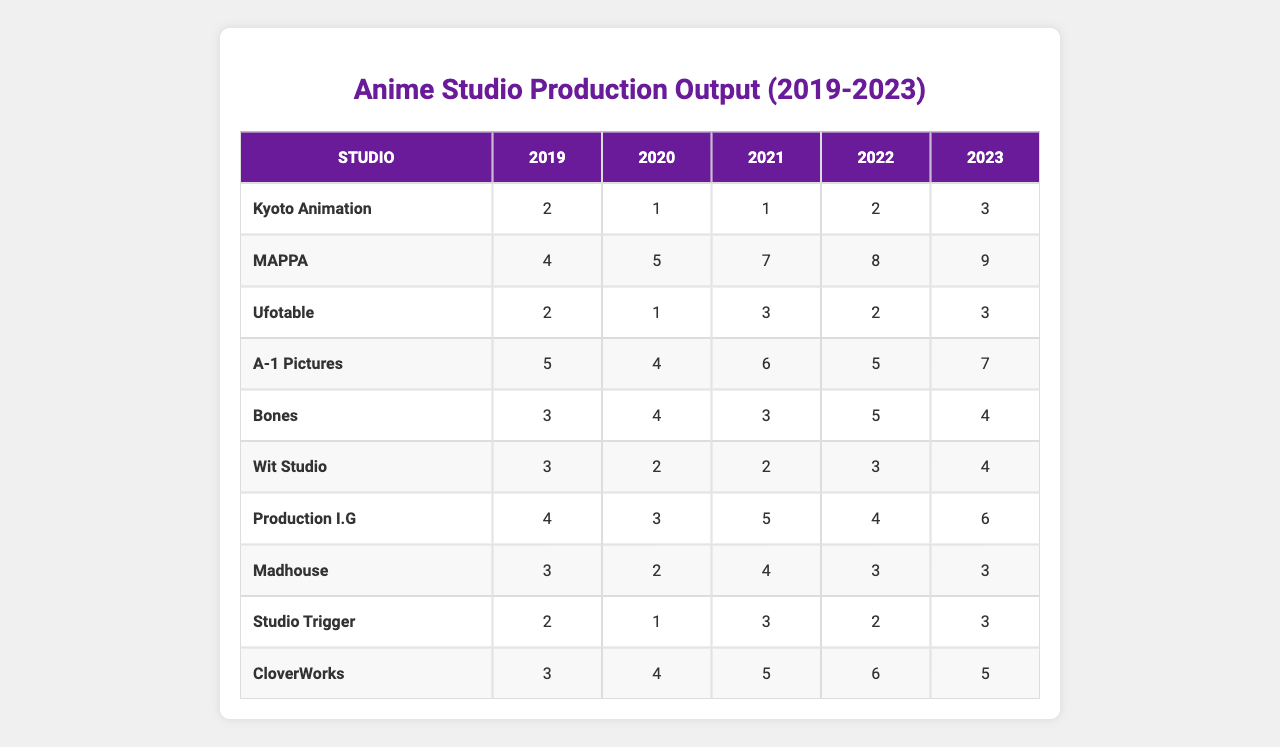What studio had the highest production output in 2023? By looking at the values indicated for each studio in 2023, MAPPA has the highest output with 9 productions.
Answer: MAPPA How many productions did A-1 Pictures have in total from 2019 to 2023? The output values for A-1 Pictures from 2019 to 2023 are 5, 4, 6, 5, and 7. Summing these values gives 5 + 4 + 6 + 5 + 7 = 27.
Answer: 27 Which studio saw the most significant increase in production output from 2019 to 2023? The studio with the highest difference between 2019 and 2023 is MAPPA, which increased from 4 to 9, a difference of 5. No other studio had a larger increase over this period.
Answer: MAPPA What was the average production output for Production I.G over the last five years? The production outputs for Production I.G from 2019 to 2023 are 4, 3, 5, 4, and 6. Adding these gives 4 + 3 + 5 + 4 + 6 = 22. Since there are 5 data points, the average is 22/5 = 4.4.
Answer: 4.4 Did Studio Trigger have an increase in production output every year from 2019 to 2023? Examining the data, Studio Trigger's production output went from 2 in 2019 to 1 in 2020, which is a decrease. Therefore, it did not have an increase every year.
Answer: No How does the production output of Ufotable in 2021 compare to its output in 2022? Ufotable had a production output of 3 in 2021 and 2 in 2022. Therefore, the output in 2021 was greater.
Answer: 2021 was greater Which two studios had the same production output in 2020? Both Ufotable and Studio Trigger had a production output of 1 in 2020.
Answer: Ufotable and Studio Trigger What is the total production output for CloverWorks over the past five years? The outputs for CloverWorks from 2019 to 2023 are 3, 4, 5, 6, and 5. Summing these gives 3 + 4 + 5 + 6 + 5 = 23.
Answer: 23 Which studio had lower production output in 2022 compared to 2019? Examining Kyoto Animation, it had 2 in 2019 and 2 in 2022, while Bones had 3 in 2019 and 5 in 2022. In contrast, Madhouse had 3 in 2019 and 3 in 2022. Thus, only Ufotable decreased from 2 in 2019 to 2 in 2022.
Answer: Ufotable How many studios produced more than 5 productions in 2023? Checking the output for each studio, only MAPPA (9) and A-1 Pictures (7) had more than 5 productions. Thus, there are 2 studios.
Answer: 2 